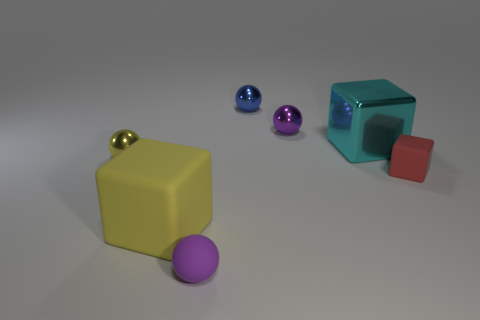Add 1 big yellow matte cylinders. How many objects exist? 8 Subtract all blocks. How many objects are left? 4 Add 3 yellow metallic objects. How many yellow metallic objects are left? 4 Add 3 green cylinders. How many green cylinders exist? 3 Subtract 0 red cylinders. How many objects are left? 7 Subtract all small red matte cubes. Subtract all metal things. How many objects are left? 2 